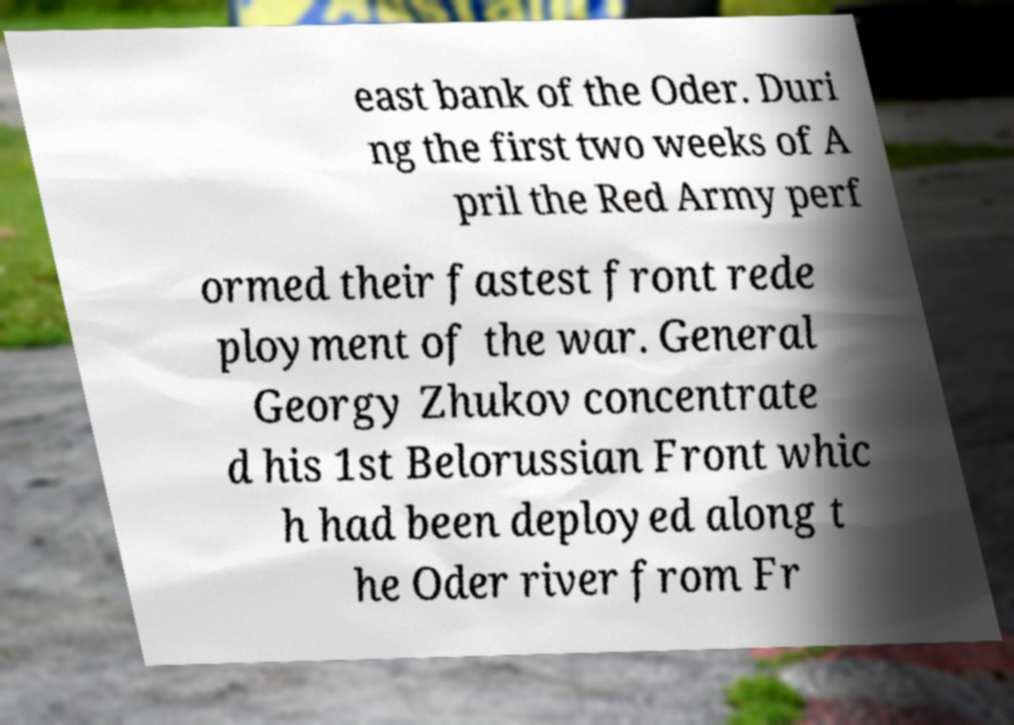What messages or text are displayed in this image? I need them in a readable, typed format. east bank of the Oder. Duri ng the first two weeks of A pril the Red Army perf ormed their fastest front rede ployment of the war. General Georgy Zhukov concentrate d his 1st Belorussian Front whic h had been deployed along t he Oder river from Fr 